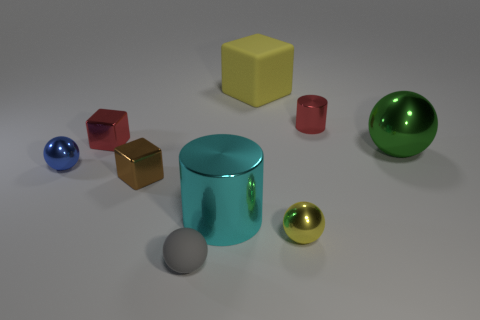What is the size of the shiny block that is in front of the green ball?
Give a very brief answer. Small. How many other objects are there of the same shape as the big green metallic thing?
Your response must be concise. 3. Do the small metallic cylinder and the metal block that is behind the blue metallic ball have the same color?
Provide a succinct answer. Yes. Do the ball on the left side of the tiny gray sphere and the matte thing behind the tiny rubber ball have the same size?
Keep it short and to the point. No. What material is the tiny thing that is the same color as the big block?
Provide a short and direct response. Metal. Is the number of blocks in front of the tiny red metal block greater than the number of big blue matte blocks?
Offer a terse response. Yes. Is the shape of the gray thing the same as the yellow shiny object?
Your answer should be compact. Yes. What number of blue spheres have the same material as the green sphere?
Your answer should be compact. 1. There is a brown thing that is the same shape as the large yellow rubber object; what is its size?
Make the answer very short. Small. Do the cyan metallic cylinder and the red block have the same size?
Keep it short and to the point. No. 